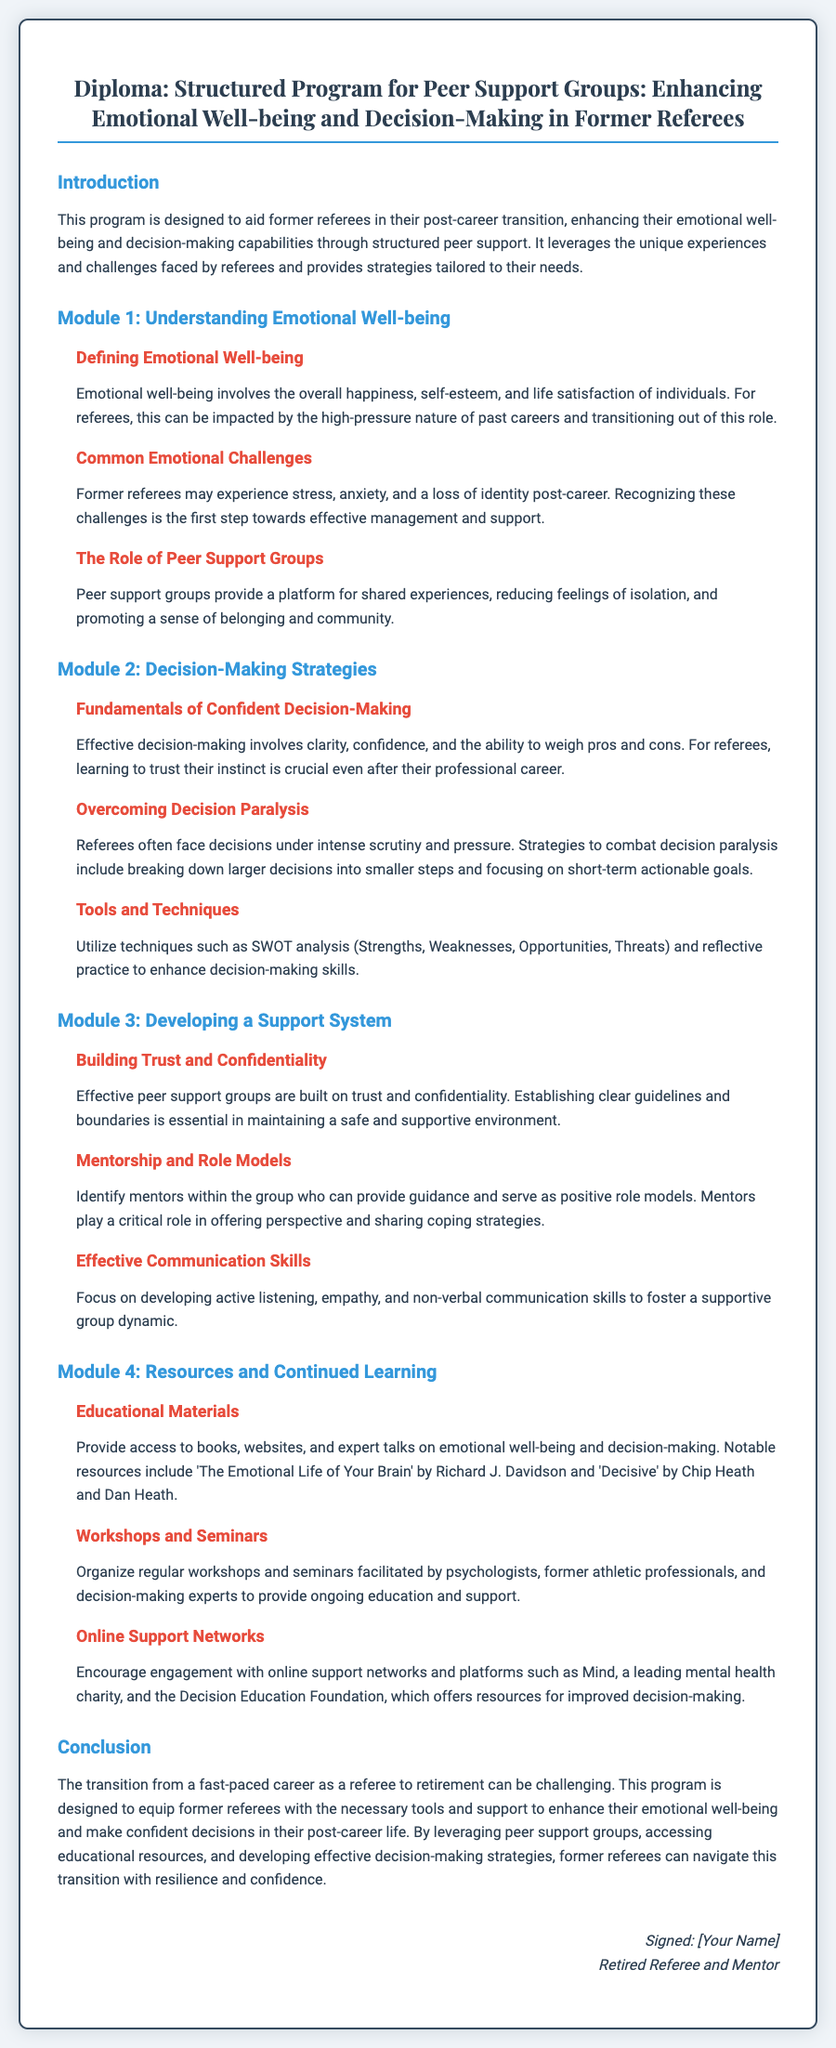What is the title of the diploma? The title of the diploma is found in the header of the document, reflecting the primary focus of the program.
Answer: Structured Program for Peer Support Groups: Enhancing Emotional Well-being and Decision-Making in Former Referees What does Module 1 focus on? The document lists the subject of each module, with Module 1 specifically addressing emotional well-being.
Answer: Understanding Emotional Well-being What are some Common Emotional Challenges faced by former referees? The section lists emotional challenges, providing a few types that former referees may experience.
Answer: Stress, anxiety, and a loss of identity What technique is suggested for enhancing decision-making skills? The document provides examples of tools and techniques for decision-making strategies.
Answer: SWOT analysis What is the purpose of peer support groups according to the document? The role of peer support groups is emphasized in the context of their function and benefits for former referees.
Answer: Reducing feelings of isolation Which book is recommended for educational materials? Specific books are mentioned as resources, focusing on emotional well-being and decision-making.
Answer: The Emotional Life of Your Brain What is the main conclusion of the program? The document summarizes the goal of the program in a concluding section, underscoring its importance to former referees.
Answer: Equip former referees with the necessary tools and support How many modules are there in the structured program? The number of modules can be counted from their headings within the document.
Answer: Four 